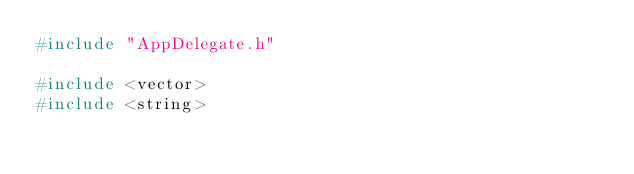Convert code to text. <code><loc_0><loc_0><loc_500><loc_500><_C++_>#include "AppDelegate.h"

#include <vector>
#include <string>
</code> 